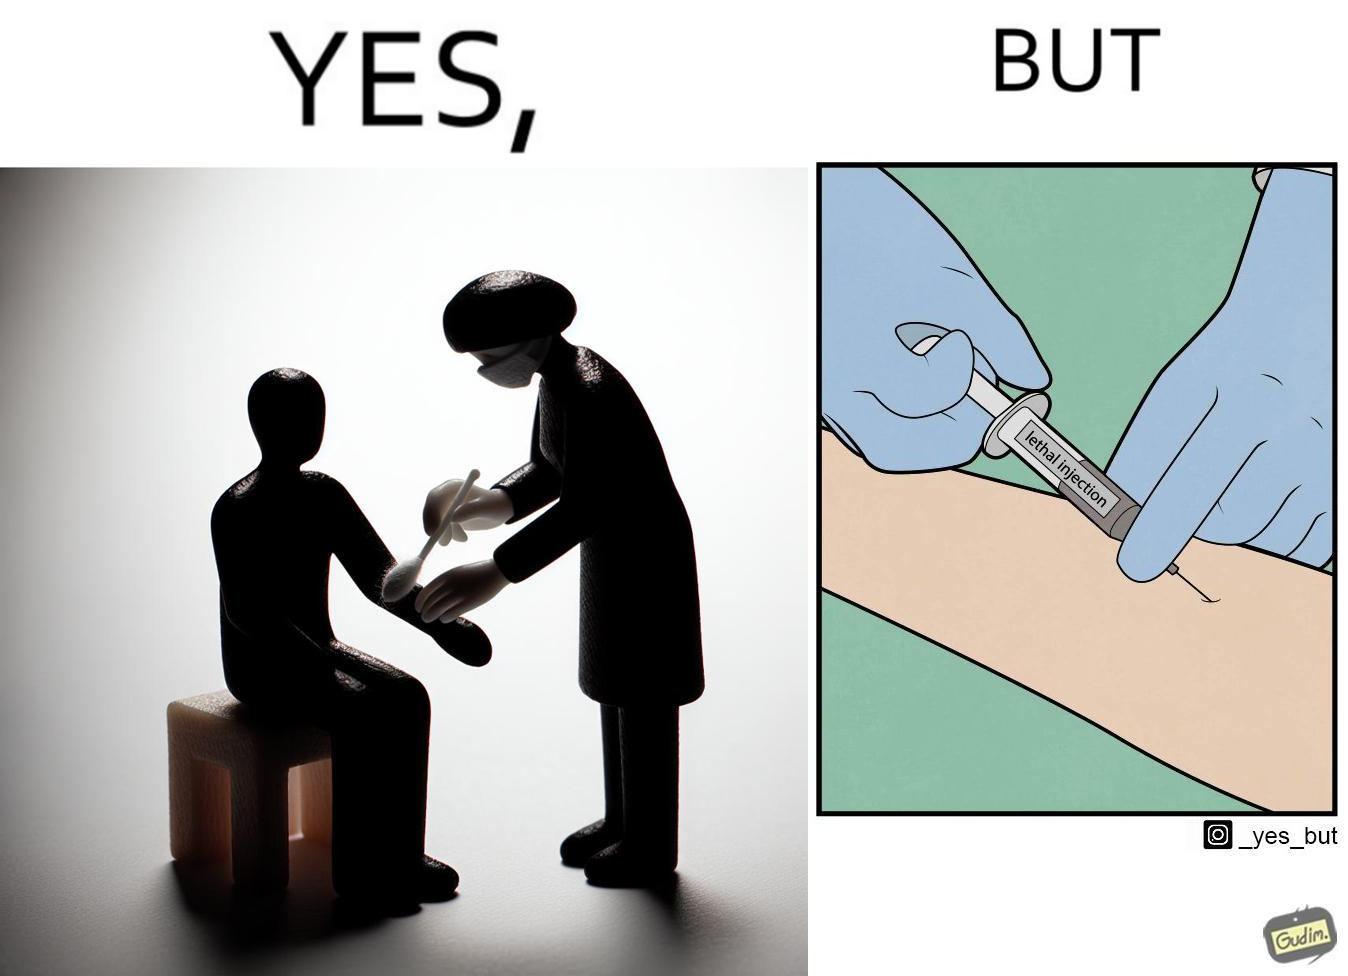Compare the left and right sides of this image. In the left part of the image: a doctor/nurse rubbing alcohol on a patient's arm. In the right part of the image: a doctor/nurse injecting a 'lethal injection' into the patient's arm. 